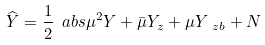Convert formula to latex. <formula><loc_0><loc_0><loc_500><loc_500>\widehat { Y } = \frac { 1 } { 2 } \ a b s { \mu } ^ { 2 } Y + \bar { \mu } Y _ { z } + \mu Y _ { \ z b } + N</formula> 